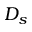Convert formula to latex. <formula><loc_0><loc_0><loc_500><loc_500>D _ { s }</formula> 